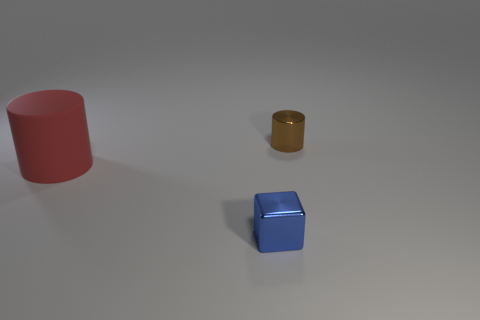What color is the cylinder that is the same material as the cube?
Ensure brevity in your answer.  Brown. Is there anything else that is the same size as the blue object?
Provide a short and direct response. Yes. Is the color of the metal object that is in front of the brown object the same as the object on the right side of the tiny blue object?
Provide a succinct answer. No. Are there more small brown objects that are on the right side of the tiny cylinder than red matte things in front of the large thing?
Ensure brevity in your answer.  No. There is a tiny metallic thing that is the same shape as the large red matte thing; what color is it?
Offer a terse response. Brown. Is there any other thing that has the same shape as the large red matte thing?
Provide a short and direct response. Yes. Is the shape of the red thing the same as the tiny object behind the big cylinder?
Provide a short and direct response. Yes. How many other objects are the same material as the brown cylinder?
Make the answer very short. 1. There is a thing that is to the right of the tiny block; what is its material?
Your answer should be very brief. Metal. There is a cube that is the same size as the brown cylinder; what color is it?
Offer a terse response. Blue. 